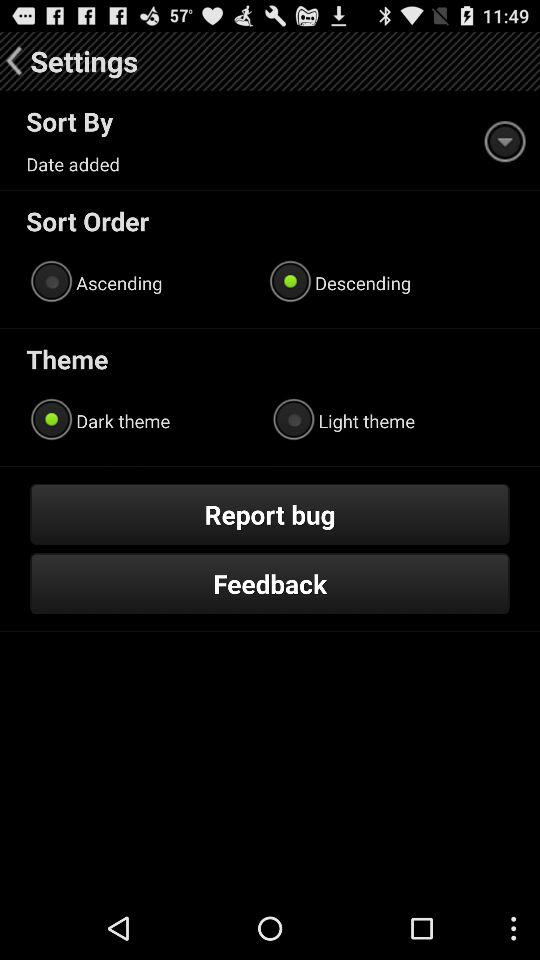Which theme has been selected? The selected theme is "Dark theme". 